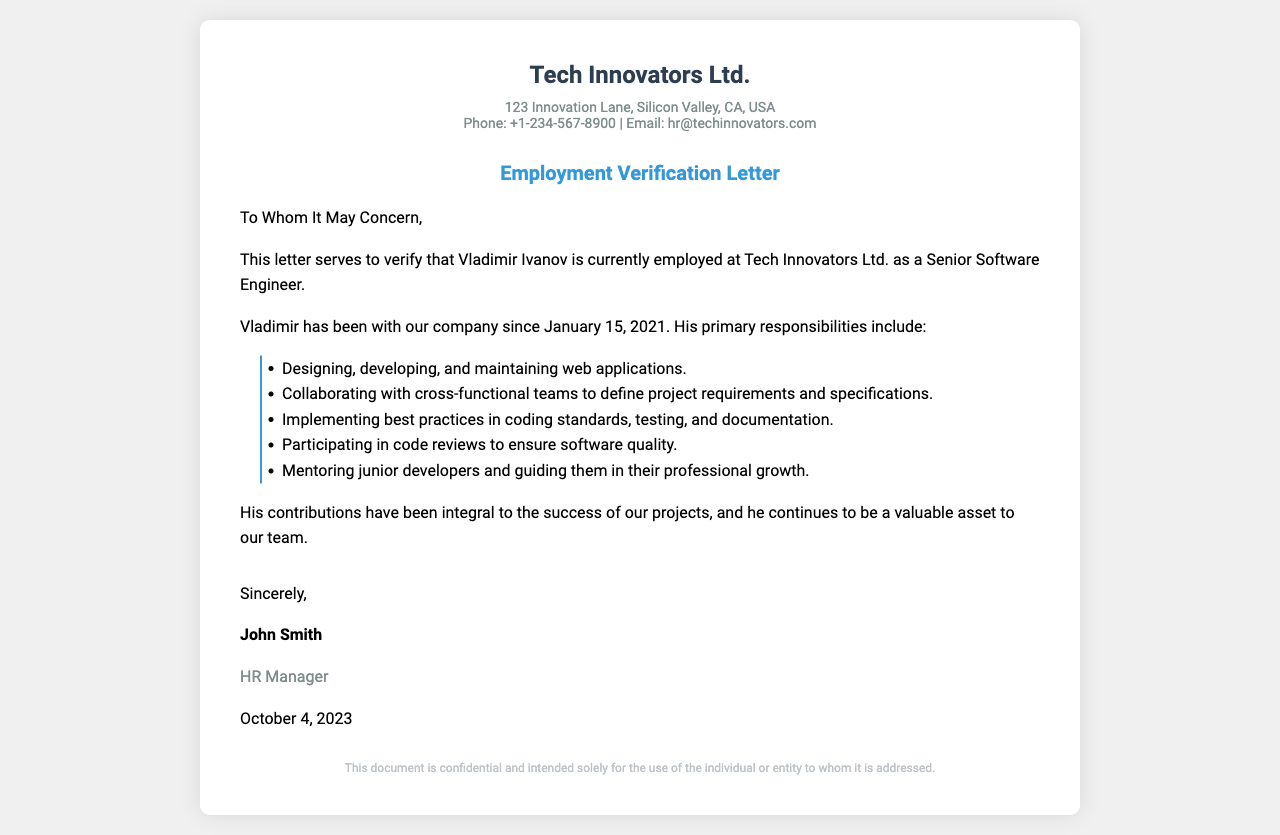What is the employee's name? The letter specifies that the employee's name is mentioned at the beginning; it is "Vladimir Ivanov."
Answer: Vladimir Ivanov What is Vladimir's job title? The document clearly states his title as "Senior Software Engineer."
Answer: Senior Software Engineer When did Vladimir join the company? The date of employment is provided in the letter as "January 15, 2021."
Answer: January 15, 2021 Who is the signatory of the letter? The last section indicates the person who signed the letter; it is "John Smith."
Answer: John Smith What is the name of the company? The letter lists the company name at the top; it is "Tech Innovators Ltd."
Answer: Tech Innovators Ltd What is the primary responsibility of Vladimir in relation to web applications? One of the responsibilities listed specifies "Designing, developing, and maintaining web applications."
Answer: Designing, developing, and maintaining web applications How many years has Vladimir worked at the company as of the date of the letter? The letter states he joined in January 2021, and the letter is dated October 4, 2023; thus, he has worked for approximately 2 years and 9 months.
Answer: Approximately 2 years and 9 months What role does Vladimir have regarding junior developers? One responsibility notes that he is involved in "Mentoring junior developers and guiding them in their professional growth."
Answer: Mentoring junior developers What does the HR manager's title indicate about the nature of the document? The document is verified and signed by the HR manager, implying it is an official communication regarding employment.
Answer: Official communication regarding employment 